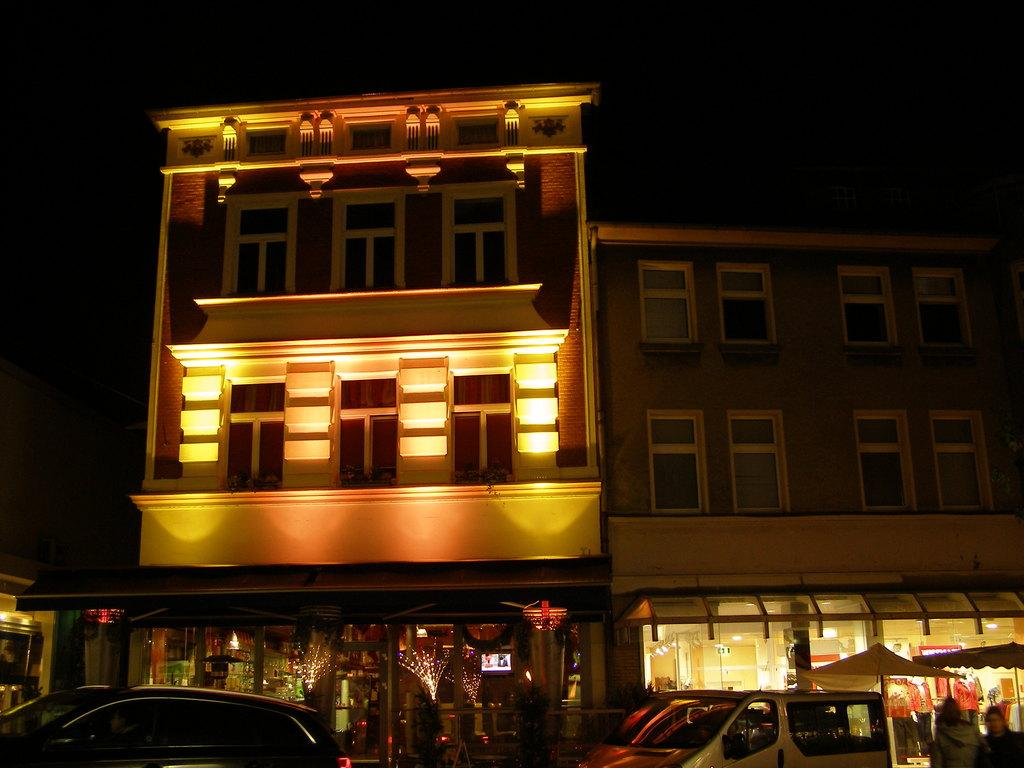What type of structures are visible in the image? There are buildings with windows in the image. What type of establishments can be found in these buildings? There are stores in the image. What else can be seen in the image besides buildings and stores? There are vehicles in the image. How would you describe the lighting in the image? The background of the image is dark. Where is the faucet located in the image? There is no faucet present in the image. What type of secretary is working in the store in the image? There is no secretary present in the image; it only shows buildings, stores, and vehicles. 